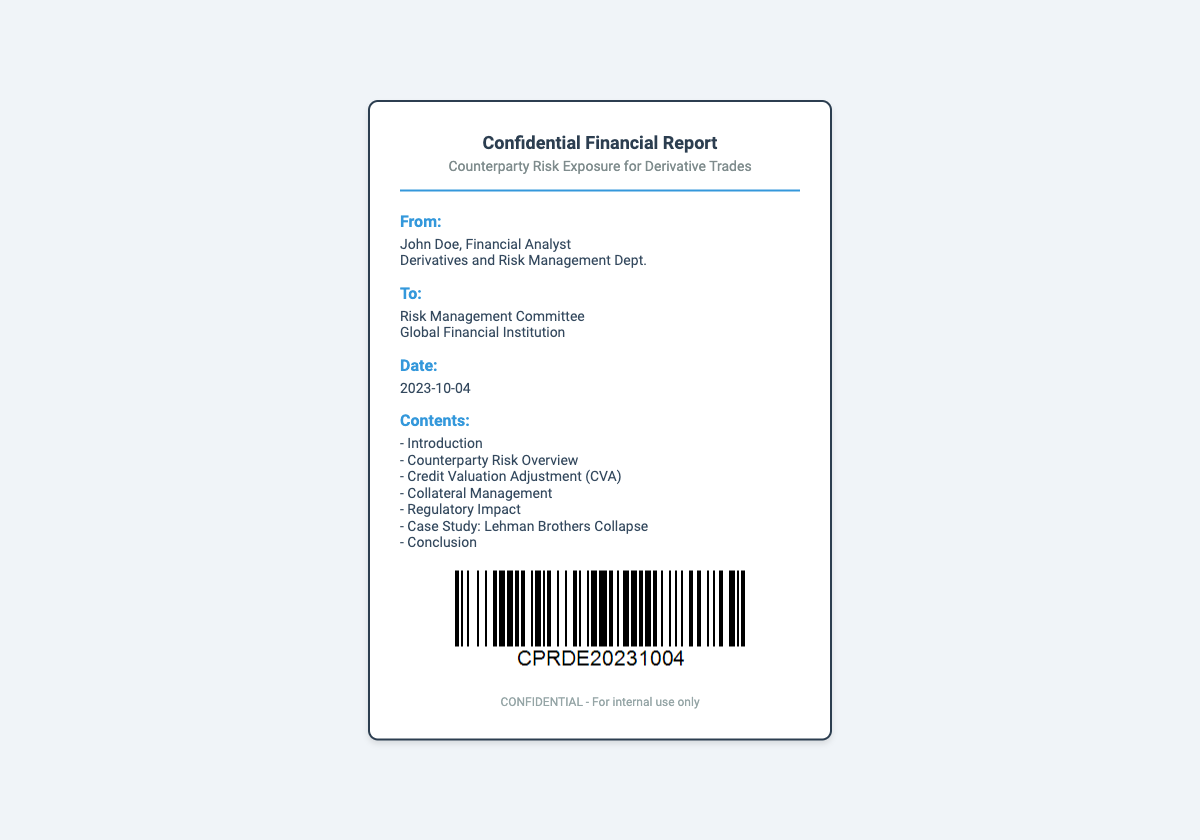what is the title of the report? The title of the report is displayed prominently in the header section of the document.
Answer: Confidential Financial Report who is the sender of the report? The sender is identified in the "From:" section of the document.
Answer: John Doe what is the recipient's title? The title of the recipient can be found under the "To:" section of the document.
Answer: Risk Management Committee when was the report date? The date of the report is clearly stated in the "Date:" section of the document.
Answer: 2023-10-04 what is included in the report contents? The contents provide an outline of the main sections included in the report.
Answer: Introduction, Counterparty Risk Overview, Credit Valuation Adjustment (CVA), Collateral Management, Regulatory Impact, Case Study: Lehman Brothers Collapse, Conclusion how many sections are listed under "Contents"? The number of sections is counted from the listed items in the "Contents" section.
Answer: Seven who is the department associated with the sender? The associated department is mentioned under the "From:" section of the document.
Answer: Derivatives and Risk Management Dept what is the confidentiality notice in the footer? The confidentiality notice is included in the footer section of the document.
Answer: CONFIDENTIAL - For internal use only 